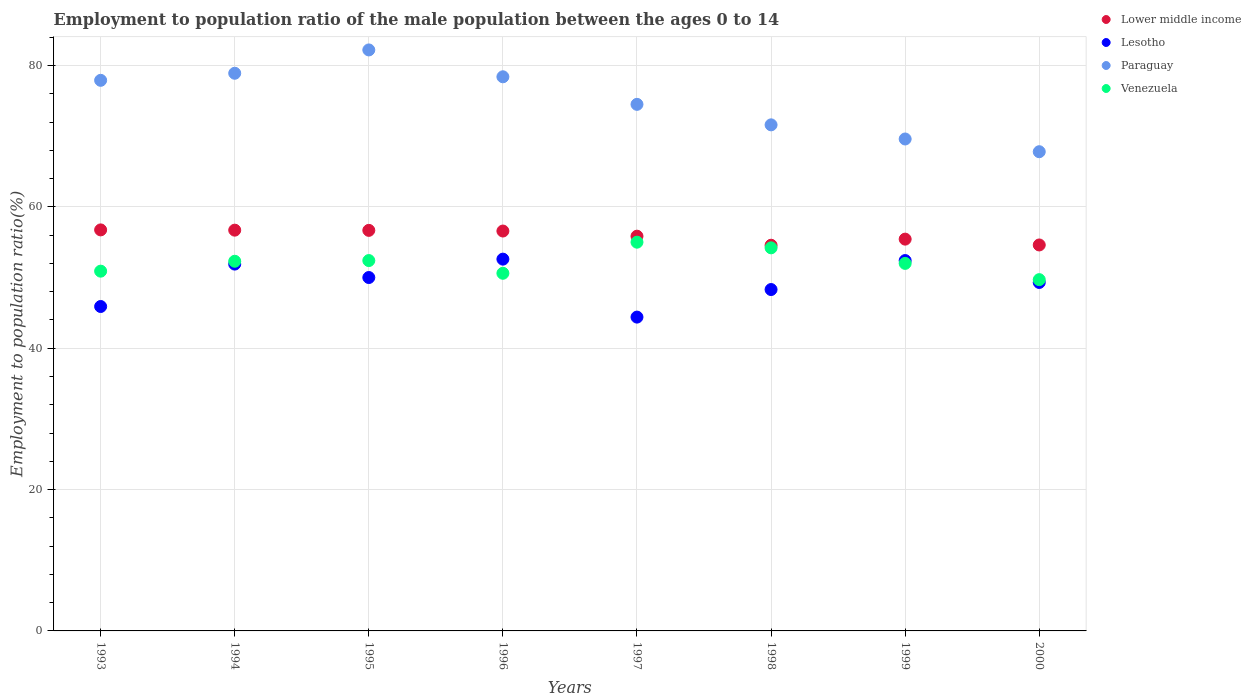How many different coloured dotlines are there?
Offer a very short reply. 4. Is the number of dotlines equal to the number of legend labels?
Your answer should be very brief. Yes. What is the employment to population ratio in Venezuela in 1996?
Your response must be concise. 50.6. Across all years, what is the maximum employment to population ratio in Lower middle income?
Give a very brief answer. 56.74. Across all years, what is the minimum employment to population ratio in Paraguay?
Your response must be concise. 67.8. In which year was the employment to population ratio in Paraguay minimum?
Your answer should be very brief. 2000. What is the total employment to population ratio in Lesotho in the graph?
Provide a succinct answer. 394.8. What is the difference between the employment to population ratio in Paraguay in 1997 and that in 2000?
Your answer should be compact. 6.7. What is the difference between the employment to population ratio in Paraguay in 1995 and the employment to population ratio in Lesotho in 1996?
Your answer should be compact. 29.6. What is the average employment to population ratio in Lesotho per year?
Your answer should be very brief. 49.35. In the year 1999, what is the difference between the employment to population ratio in Venezuela and employment to population ratio in Paraguay?
Keep it short and to the point. -17.6. What is the ratio of the employment to population ratio in Lower middle income in 1995 to that in 1996?
Provide a short and direct response. 1. Is the difference between the employment to population ratio in Venezuela in 1993 and 1999 greater than the difference between the employment to population ratio in Paraguay in 1993 and 1999?
Keep it short and to the point. No. What is the difference between the highest and the second highest employment to population ratio in Lesotho?
Make the answer very short. 0.2. What is the difference between the highest and the lowest employment to population ratio in Paraguay?
Ensure brevity in your answer.  14.4. In how many years, is the employment to population ratio in Lesotho greater than the average employment to population ratio in Lesotho taken over all years?
Make the answer very short. 4. Is the employment to population ratio in Venezuela strictly less than the employment to population ratio in Paraguay over the years?
Offer a very short reply. Yes. Are the values on the major ticks of Y-axis written in scientific E-notation?
Your answer should be compact. No. Does the graph contain any zero values?
Provide a succinct answer. No. Does the graph contain grids?
Offer a very short reply. Yes. Where does the legend appear in the graph?
Give a very brief answer. Top right. How many legend labels are there?
Your answer should be compact. 4. How are the legend labels stacked?
Offer a very short reply. Vertical. What is the title of the graph?
Your answer should be very brief. Employment to population ratio of the male population between the ages 0 to 14. What is the label or title of the X-axis?
Your answer should be compact. Years. What is the Employment to population ratio(%) of Lower middle income in 1993?
Make the answer very short. 56.74. What is the Employment to population ratio(%) of Lesotho in 1993?
Your response must be concise. 45.9. What is the Employment to population ratio(%) in Paraguay in 1993?
Ensure brevity in your answer.  77.9. What is the Employment to population ratio(%) of Venezuela in 1993?
Give a very brief answer. 50.9. What is the Employment to population ratio(%) in Lower middle income in 1994?
Provide a short and direct response. 56.7. What is the Employment to population ratio(%) in Lesotho in 1994?
Your answer should be compact. 51.9. What is the Employment to population ratio(%) in Paraguay in 1994?
Keep it short and to the point. 78.9. What is the Employment to population ratio(%) of Venezuela in 1994?
Make the answer very short. 52.3. What is the Employment to population ratio(%) of Lower middle income in 1995?
Your response must be concise. 56.67. What is the Employment to population ratio(%) in Paraguay in 1995?
Offer a terse response. 82.2. What is the Employment to population ratio(%) in Venezuela in 1995?
Your answer should be very brief. 52.4. What is the Employment to population ratio(%) in Lower middle income in 1996?
Ensure brevity in your answer.  56.58. What is the Employment to population ratio(%) in Lesotho in 1996?
Your answer should be very brief. 52.6. What is the Employment to population ratio(%) in Paraguay in 1996?
Give a very brief answer. 78.4. What is the Employment to population ratio(%) in Venezuela in 1996?
Provide a succinct answer. 50.6. What is the Employment to population ratio(%) in Lower middle income in 1997?
Your response must be concise. 55.85. What is the Employment to population ratio(%) of Lesotho in 1997?
Make the answer very short. 44.4. What is the Employment to population ratio(%) of Paraguay in 1997?
Your answer should be very brief. 74.5. What is the Employment to population ratio(%) of Venezuela in 1997?
Offer a very short reply. 55. What is the Employment to population ratio(%) in Lower middle income in 1998?
Your answer should be very brief. 54.57. What is the Employment to population ratio(%) in Lesotho in 1998?
Provide a succinct answer. 48.3. What is the Employment to population ratio(%) of Paraguay in 1998?
Keep it short and to the point. 71.6. What is the Employment to population ratio(%) in Venezuela in 1998?
Offer a very short reply. 54.2. What is the Employment to population ratio(%) in Lower middle income in 1999?
Offer a terse response. 55.43. What is the Employment to population ratio(%) of Lesotho in 1999?
Make the answer very short. 52.4. What is the Employment to population ratio(%) of Paraguay in 1999?
Give a very brief answer. 69.6. What is the Employment to population ratio(%) in Lower middle income in 2000?
Offer a terse response. 54.61. What is the Employment to population ratio(%) of Lesotho in 2000?
Provide a short and direct response. 49.3. What is the Employment to population ratio(%) in Paraguay in 2000?
Keep it short and to the point. 67.8. What is the Employment to population ratio(%) in Venezuela in 2000?
Ensure brevity in your answer.  49.7. Across all years, what is the maximum Employment to population ratio(%) in Lower middle income?
Offer a very short reply. 56.74. Across all years, what is the maximum Employment to population ratio(%) of Lesotho?
Your answer should be compact. 52.6. Across all years, what is the maximum Employment to population ratio(%) in Paraguay?
Make the answer very short. 82.2. Across all years, what is the minimum Employment to population ratio(%) in Lower middle income?
Your response must be concise. 54.57. Across all years, what is the minimum Employment to population ratio(%) of Lesotho?
Make the answer very short. 44.4. Across all years, what is the minimum Employment to population ratio(%) in Paraguay?
Keep it short and to the point. 67.8. Across all years, what is the minimum Employment to population ratio(%) of Venezuela?
Offer a terse response. 49.7. What is the total Employment to population ratio(%) in Lower middle income in the graph?
Your answer should be very brief. 447.14. What is the total Employment to population ratio(%) of Lesotho in the graph?
Your response must be concise. 394.8. What is the total Employment to population ratio(%) in Paraguay in the graph?
Provide a short and direct response. 600.9. What is the total Employment to population ratio(%) of Venezuela in the graph?
Your response must be concise. 417.1. What is the difference between the Employment to population ratio(%) in Lower middle income in 1993 and that in 1994?
Provide a succinct answer. 0.04. What is the difference between the Employment to population ratio(%) in Paraguay in 1993 and that in 1994?
Your answer should be very brief. -1. What is the difference between the Employment to population ratio(%) of Venezuela in 1993 and that in 1994?
Your answer should be compact. -1.4. What is the difference between the Employment to population ratio(%) in Lower middle income in 1993 and that in 1995?
Offer a terse response. 0.07. What is the difference between the Employment to population ratio(%) in Paraguay in 1993 and that in 1995?
Give a very brief answer. -4.3. What is the difference between the Employment to population ratio(%) of Lower middle income in 1993 and that in 1996?
Offer a terse response. 0.16. What is the difference between the Employment to population ratio(%) in Paraguay in 1993 and that in 1996?
Offer a terse response. -0.5. What is the difference between the Employment to population ratio(%) of Venezuela in 1993 and that in 1996?
Your answer should be very brief. 0.3. What is the difference between the Employment to population ratio(%) of Lower middle income in 1993 and that in 1997?
Your answer should be very brief. 0.89. What is the difference between the Employment to population ratio(%) of Paraguay in 1993 and that in 1997?
Provide a succinct answer. 3.4. What is the difference between the Employment to population ratio(%) of Venezuela in 1993 and that in 1997?
Ensure brevity in your answer.  -4.1. What is the difference between the Employment to population ratio(%) of Lower middle income in 1993 and that in 1998?
Give a very brief answer. 2.17. What is the difference between the Employment to population ratio(%) in Lesotho in 1993 and that in 1998?
Make the answer very short. -2.4. What is the difference between the Employment to population ratio(%) in Paraguay in 1993 and that in 1998?
Give a very brief answer. 6.3. What is the difference between the Employment to population ratio(%) in Venezuela in 1993 and that in 1998?
Ensure brevity in your answer.  -3.3. What is the difference between the Employment to population ratio(%) in Lower middle income in 1993 and that in 1999?
Give a very brief answer. 1.31. What is the difference between the Employment to population ratio(%) of Venezuela in 1993 and that in 1999?
Your answer should be compact. -1.1. What is the difference between the Employment to population ratio(%) of Lower middle income in 1993 and that in 2000?
Ensure brevity in your answer.  2.13. What is the difference between the Employment to population ratio(%) in Lesotho in 1993 and that in 2000?
Offer a terse response. -3.4. What is the difference between the Employment to population ratio(%) of Lower middle income in 1994 and that in 1995?
Provide a short and direct response. 0.03. What is the difference between the Employment to population ratio(%) of Venezuela in 1994 and that in 1995?
Offer a very short reply. -0.1. What is the difference between the Employment to population ratio(%) of Lower middle income in 1994 and that in 1996?
Provide a short and direct response. 0.12. What is the difference between the Employment to population ratio(%) in Lesotho in 1994 and that in 1996?
Offer a very short reply. -0.7. What is the difference between the Employment to population ratio(%) of Paraguay in 1994 and that in 1996?
Keep it short and to the point. 0.5. What is the difference between the Employment to population ratio(%) of Venezuela in 1994 and that in 1996?
Your response must be concise. 1.7. What is the difference between the Employment to population ratio(%) in Lower middle income in 1994 and that in 1997?
Provide a succinct answer. 0.85. What is the difference between the Employment to population ratio(%) of Lesotho in 1994 and that in 1997?
Ensure brevity in your answer.  7.5. What is the difference between the Employment to population ratio(%) of Lower middle income in 1994 and that in 1998?
Offer a terse response. 2.13. What is the difference between the Employment to population ratio(%) of Venezuela in 1994 and that in 1998?
Your answer should be very brief. -1.9. What is the difference between the Employment to population ratio(%) in Lower middle income in 1994 and that in 1999?
Ensure brevity in your answer.  1.27. What is the difference between the Employment to population ratio(%) in Lesotho in 1994 and that in 1999?
Your answer should be compact. -0.5. What is the difference between the Employment to population ratio(%) in Lower middle income in 1994 and that in 2000?
Make the answer very short. 2.1. What is the difference between the Employment to population ratio(%) in Venezuela in 1994 and that in 2000?
Provide a short and direct response. 2.6. What is the difference between the Employment to population ratio(%) in Lower middle income in 1995 and that in 1996?
Provide a succinct answer. 0.09. What is the difference between the Employment to population ratio(%) of Venezuela in 1995 and that in 1996?
Provide a short and direct response. 1.8. What is the difference between the Employment to population ratio(%) of Lower middle income in 1995 and that in 1997?
Provide a succinct answer. 0.82. What is the difference between the Employment to population ratio(%) in Lesotho in 1995 and that in 1997?
Offer a very short reply. 5.6. What is the difference between the Employment to population ratio(%) in Lower middle income in 1995 and that in 1998?
Give a very brief answer. 2.1. What is the difference between the Employment to population ratio(%) of Lesotho in 1995 and that in 1998?
Offer a terse response. 1.7. What is the difference between the Employment to population ratio(%) of Venezuela in 1995 and that in 1998?
Give a very brief answer. -1.8. What is the difference between the Employment to population ratio(%) in Lower middle income in 1995 and that in 1999?
Provide a short and direct response. 1.24. What is the difference between the Employment to population ratio(%) of Lesotho in 1995 and that in 1999?
Provide a succinct answer. -2.4. What is the difference between the Employment to population ratio(%) of Paraguay in 1995 and that in 1999?
Your answer should be very brief. 12.6. What is the difference between the Employment to population ratio(%) in Venezuela in 1995 and that in 1999?
Your response must be concise. 0.4. What is the difference between the Employment to population ratio(%) in Lower middle income in 1995 and that in 2000?
Offer a terse response. 2.07. What is the difference between the Employment to population ratio(%) of Paraguay in 1995 and that in 2000?
Your answer should be compact. 14.4. What is the difference between the Employment to population ratio(%) of Venezuela in 1995 and that in 2000?
Provide a short and direct response. 2.7. What is the difference between the Employment to population ratio(%) of Lower middle income in 1996 and that in 1997?
Your response must be concise. 0.73. What is the difference between the Employment to population ratio(%) in Paraguay in 1996 and that in 1997?
Make the answer very short. 3.9. What is the difference between the Employment to population ratio(%) of Venezuela in 1996 and that in 1997?
Keep it short and to the point. -4.4. What is the difference between the Employment to population ratio(%) in Lower middle income in 1996 and that in 1998?
Your answer should be compact. 2.01. What is the difference between the Employment to population ratio(%) in Lesotho in 1996 and that in 1998?
Provide a succinct answer. 4.3. What is the difference between the Employment to population ratio(%) of Paraguay in 1996 and that in 1998?
Offer a terse response. 6.8. What is the difference between the Employment to population ratio(%) in Lower middle income in 1996 and that in 1999?
Provide a short and direct response. 1.15. What is the difference between the Employment to population ratio(%) of Venezuela in 1996 and that in 1999?
Make the answer very short. -1.4. What is the difference between the Employment to population ratio(%) in Lower middle income in 1996 and that in 2000?
Your answer should be compact. 1.97. What is the difference between the Employment to population ratio(%) in Lesotho in 1996 and that in 2000?
Your answer should be compact. 3.3. What is the difference between the Employment to population ratio(%) of Venezuela in 1996 and that in 2000?
Ensure brevity in your answer.  0.9. What is the difference between the Employment to population ratio(%) in Lower middle income in 1997 and that in 1998?
Give a very brief answer. 1.28. What is the difference between the Employment to population ratio(%) in Venezuela in 1997 and that in 1998?
Your answer should be very brief. 0.8. What is the difference between the Employment to population ratio(%) of Lower middle income in 1997 and that in 1999?
Provide a short and direct response. 0.42. What is the difference between the Employment to population ratio(%) in Paraguay in 1997 and that in 1999?
Your response must be concise. 4.9. What is the difference between the Employment to population ratio(%) in Lower middle income in 1997 and that in 2000?
Offer a very short reply. 1.24. What is the difference between the Employment to population ratio(%) in Lesotho in 1997 and that in 2000?
Your response must be concise. -4.9. What is the difference between the Employment to population ratio(%) of Lower middle income in 1998 and that in 1999?
Offer a very short reply. -0.86. What is the difference between the Employment to population ratio(%) of Lower middle income in 1998 and that in 2000?
Give a very brief answer. -0.04. What is the difference between the Employment to population ratio(%) in Lesotho in 1998 and that in 2000?
Keep it short and to the point. -1. What is the difference between the Employment to population ratio(%) of Paraguay in 1998 and that in 2000?
Offer a very short reply. 3.8. What is the difference between the Employment to population ratio(%) in Lower middle income in 1999 and that in 2000?
Ensure brevity in your answer.  0.83. What is the difference between the Employment to population ratio(%) of Lower middle income in 1993 and the Employment to population ratio(%) of Lesotho in 1994?
Give a very brief answer. 4.84. What is the difference between the Employment to population ratio(%) in Lower middle income in 1993 and the Employment to population ratio(%) in Paraguay in 1994?
Offer a very short reply. -22.16. What is the difference between the Employment to population ratio(%) of Lower middle income in 1993 and the Employment to population ratio(%) of Venezuela in 1994?
Your answer should be compact. 4.44. What is the difference between the Employment to population ratio(%) of Lesotho in 1993 and the Employment to population ratio(%) of Paraguay in 1994?
Offer a terse response. -33. What is the difference between the Employment to population ratio(%) of Paraguay in 1993 and the Employment to population ratio(%) of Venezuela in 1994?
Your answer should be very brief. 25.6. What is the difference between the Employment to population ratio(%) of Lower middle income in 1993 and the Employment to population ratio(%) of Lesotho in 1995?
Your response must be concise. 6.74. What is the difference between the Employment to population ratio(%) of Lower middle income in 1993 and the Employment to population ratio(%) of Paraguay in 1995?
Offer a terse response. -25.46. What is the difference between the Employment to population ratio(%) in Lower middle income in 1993 and the Employment to population ratio(%) in Venezuela in 1995?
Your answer should be compact. 4.34. What is the difference between the Employment to population ratio(%) in Lesotho in 1993 and the Employment to population ratio(%) in Paraguay in 1995?
Your response must be concise. -36.3. What is the difference between the Employment to population ratio(%) of Lower middle income in 1993 and the Employment to population ratio(%) of Lesotho in 1996?
Offer a terse response. 4.14. What is the difference between the Employment to population ratio(%) of Lower middle income in 1993 and the Employment to population ratio(%) of Paraguay in 1996?
Your answer should be compact. -21.66. What is the difference between the Employment to population ratio(%) in Lower middle income in 1993 and the Employment to population ratio(%) in Venezuela in 1996?
Keep it short and to the point. 6.14. What is the difference between the Employment to population ratio(%) in Lesotho in 1993 and the Employment to population ratio(%) in Paraguay in 1996?
Provide a short and direct response. -32.5. What is the difference between the Employment to population ratio(%) of Paraguay in 1993 and the Employment to population ratio(%) of Venezuela in 1996?
Your answer should be compact. 27.3. What is the difference between the Employment to population ratio(%) in Lower middle income in 1993 and the Employment to population ratio(%) in Lesotho in 1997?
Offer a very short reply. 12.34. What is the difference between the Employment to population ratio(%) of Lower middle income in 1993 and the Employment to population ratio(%) of Paraguay in 1997?
Give a very brief answer. -17.76. What is the difference between the Employment to population ratio(%) of Lower middle income in 1993 and the Employment to population ratio(%) of Venezuela in 1997?
Offer a terse response. 1.74. What is the difference between the Employment to population ratio(%) in Lesotho in 1993 and the Employment to population ratio(%) in Paraguay in 1997?
Provide a short and direct response. -28.6. What is the difference between the Employment to population ratio(%) in Lesotho in 1993 and the Employment to population ratio(%) in Venezuela in 1997?
Offer a very short reply. -9.1. What is the difference between the Employment to population ratio(%) in Paraguay in 1993 and the Employment to population ratio(%) in Venezuela in 1997?
Give a very brief answer. 22.9. What is the difference between the Employment to population ratio(%) in Lower middle income in 1993 and the Employment to population ratio(%) in Lesotho in 1998?
Ensure brevity in your answer.  8.44. What is the difference between the Employment to population ratio(%) of Lower middle income in 1993 and the Employment to population ratio(%) of Paraguay in 1998?
Your answer should be very brief. -14.86. What is the difference between the Employment to population ratio(%) of Lower middle income in 1993 and the Employment to population ratio(%) of Venezuela in 1998?
Keep it short and to the point. 2.54. What is the difference between the Employment to population ratio(%) of Lesotho in 1993 and the Employment to population ratio(%) of Paraguay in 1998?
Give a very brief answer. -25.7. What is the difference between the Employment to population ratio(%) in Lesotho in 1993 and the Employment to population ratio(%) in Venezuela in 1998?
Your response must be concise. -8.3. What is the difference between the Employment to population ratio(%) of Paraguay in 1993 and the Employment to population ratio(%) of Venezuela in 1998?
Make the answer very short. 23.7. What is the difference between the Employment to population ratio(%) of Lower middle income in 1993 and the Employment to population ratio(%) of Lesotho in 1999?
Offer a terse response. 4.34. What is the difference between the Employment to population ratio(%) in Lower middle income in 1993 and the Employment to population ratio(%) in Paraguay in 1999?
Give a very brief answer. -12.86. What is the difference between the Employment to population ratio(%) in Lower middle income in 1993 and the Employment to population ratio(%) in Venezuela in 1999?
Your response must be concise. 4.74. What is the difference between the Employment to population ratio(%) in Lesotho in 1993 and the Employment to population ratio(%) in Paraguay in 1999?
Your answer should be very brief. -23.7. What is the difference between the Employment to population ratio(%) of Paraguay in 1993 and the Employment to population ratio(%) of Venezuela in 1999?
Your response must be concise. 25.9. What is the difference between the Employment to population ratio(%) of Lower middle income in 1993 and the Employment to population ratio(%) of Lesotho in 2000?
Ensure brevity in your answer.  7.44. What is the difference between the Employment to population ratio(%) of Lower middle income in 1993 and the Employment to population ratio(%) of Paraguay in 2000?
Your response must be concise. -11.06. What is the difference between the Employment to population ratio(%) of Lower middle income in 1993 and the Employment to population ratio(%) of Venezuela in 2000?
Make the answer very short. 7.04. What is the difference between the Employment to population ratio(%) of Lesotho in 1993 and the Employment to population ratio(%) of Paraguay in 2000?
Offer a very short reply. -21.9. What is the difference between the Employment to population ratio(%) of Paraguay in 1993 and the Employment to population ratio(%) of Venezuela in 2000?
Keep it short and to the point. 28.2. What is the difference between the Employment to population ratio(%) in Lower middle income in 1994 and the Employment to population ratio(%) in Lesotho in 1995?
Your response must be concise. 6.7. What is the difference between the Employment to population ratio(%) of Lower middle income in 1994 and the Employment to population ratio(%) of Paraguay in 1995?
Your answer should be compact. -25.5. What is the difference between the Employment to population ratio(%) in Lower middle income in 1994 and the Employment to population ratio(%) in Venezuela in 1995?
Make the answer very short. 4.3. What is the difference between the Employment to population ratio(%) of Lesotho in 1994 and the Employment to population ratio(%) of Paraguay in 1995?
Give a very brief answer. -30.3. What is the difference between the Employment to population ratio(%) of Paraguay in 1994 and the Employment to population ratio(%) of Venezuela in 1995?
Provide a short and direct response. 26.5. What is the difference between the Employment to population ratio(%) in Lower middle income in 1994 and the Employment to population ratio(%) in Lesotho in 1996?
Offer a terse response. 4.1. What is the difference between the Employment to population ratio(%) of Lower middle income in 1994 and the Employment to population ratio(%) of Paraguay in 1996?
Provide a short and direct response. -21.7. What is the difference between the Employment to population ratio(%) of Lower middle income in 1994 and the Employment to population ratio(%) of Venezuela in 1996?
Provide a succinct answer. 6.1. What is the difference between the Employment to population ratio(%) in Lesotho in 1994 and the Employment to population ratio(%) in Paraguay in 1996?
Provide a succinct answer. -26.5. What is the difference between the Employment to population ratio(%) in Paraguay in 1994 and the Employment to population ratio(%) in Venezuela in 1996?
Provide a short and direct response. 28.3. What is the difference between the Employment to population ratio(%) of Lower middle income in 1994 and the Employment to population ratio(%) of Lesotho in 1997?
Provide a short and direct response. 12.3. What is the difference between the Employment to population ratio(%) in Lower middle income in 1994 and the Employment to population ratio(%) in Paraguay in 1997?
Offer a very short reply. -17.8. What is the difference between the Employment to population ratio(%) of Lower middle income in 1994 and the Employment to population ratio(%) of Venezuela in 1997?
Offer a terse response. 1.7. What is the difference between the Employment to population ratio(%) in Lesotho in 1994 and the Employment to population ratio(%) in Paraguay in 1997?
Your response must be concise. -22.6. What is the difference between the Employment to population ratio(%) of Paraguay in 1994 and the Employment to population ratio(%) of Venezuela in 1997?
Make the answer very short. 23.9. What is the difference between the Employment to population ratio(%) in Lower middle income in 1994 and the Employment to population ratio(%) in Lesotho in 1998?
Offer a terse response. 8.4. What is the difference between the Employment to population ratio(%) of Lower middle income in 1994 and the Employment to population ratio(%) of Paraguay in 1998?
Ensure brevity in your answer.  -14.9. What is the difference between the Employment to population ratio(%) in Lower middle income in 1994 and the Employment to population ratio(%) in Venezuela in 1998?
Provide a succinct answer. 2.5. What is the difference between the Employment to population ratio(%) in Lesotho in 1994 and the Employment to population ratio(%) in Paraguay in 1998?
Offer a very short reply. -19.7. What is the difference between the Employment to population ratio(%) in Lesotho in 1994 and the Employment to population ratio(%) in Venezuela in 1998?
Keep it short and to the point. -2.3. What is the difference between the Employment to population ratio(%) of Paraguay in 1994 and the Employment to population ratio(%) of Venezuela in 1998?
Your answer should be compact. 24.7. What is the difference between the Employment to population ratio(%) in Lower middle income in 1994 and the Employment to population ratio(%) in Lesotho in 1999?
Provide a short and direct response. 4.3. What is the difference between the Employment to population ratio(%) in Lower middle income in 1994 and the Employment to population ratio(%) in Paraguay in 1999?
Offer a very short reply. -12.9. What is the difference between the Employment to population ratio(%) in Lower middle income in 1994 and the Employment to population ratio(%) in Venezuela in 1999?
Make the answer very short. 4.7. What is the difference between the Employment to population ratio(%) of Lesotho in 1994 and the Employment to population ratio(%) of Paraguay in 1999?
Ensure brevity in your answer.  -17.7. What is the difference between the Employment to population ratio(%) of Paraguay in 1994 and the Employment to population ratio(%) of Venezuela in 1999?
Offer a very short reply. 26.9. What is the difference between the Employment to population ratio(%) of Lower middle income in 1994 and the Employment to population ratio(%) of Lesotho in 2000?
Provide a short and direct response. 7.4. What is the difference between the Employment to population ratio(%) in Lower middle income in 1994 and the Employment to population ratio(%) in Paraguay in 2000?
Make the answer very short. -11.1. What is the difference between the Employment to population ratio(%) in Lower middle income in 1994 and the Employment to population ratio(%) in Venezuela in 2000?
Offer a terse response. 7. What is the difference between the Employment to population ratio(%) in Lesotho in 1994 and the Employment to population ratio(%) in Paraguay in 2000?
Make the answer very short. -15.9. What is the difference between the Employment to population ratio(%) in Paraguay in 1994 and the Employment to population ratio(%) in Venezuela in 2000?
Provide a short and direct response. 29.2. What is the difference between the Employment to population ratio(%) in Lower middle income in 1995 and the Employment to population ratio(%) in Lesotho in 1996?
Offer a very short reply. 4.07. What is the difference between the Employment to population ratio(%) in Lower middle income in 1995 and the Employment to population ratio(%) in Paraguay in 1996?
Provide a short and direct response. -21.73. What is the difference between the Employment to population ratio(%) of Lower middle income in 1995 and the Employment to population ratio(%) of Venezuela in 1996?
Offer a terse response. 6.07. What is the difference between the Employment to population ratio(%) of Lesotho in 1995 and the Employment to population ratio(%) of Paraguay in 1996?
Ensure brevity in your answer.  -28.4. What is the difference between the Employment to population ratio(%) of Lesotho in 1995 and the Employment to population ratio(%) of Venezuela in 1996?
Make the answer very short. -0.6. What is the difference between the Employment to population ratio(%) of Paraguay in 1995 and the Employment to population ratio(%) of Venezuela in 1996?
Offer a very short reply. 31.6. What is the difference between the Employment to population ratio(%) of Lower middle income in 1995 and the Employment to population ratio(%) of Lesotho in 1997?
Your answer should be very brief. 12.27. What is the difference between the Employment to population ratio(%) of Lower middle income in 1995 and the Employment to population ratio(%) of Paraguay in 1997?
Ensure brevity in your answer.  -17.83. What is the difference between the Employment to population ratio(%) in Lower middle income in 1995 and the Employment to population ratio(%) in Venezuela in 1997?
Offer a terse response. 1.67. What is the difference between the Employment to population ratio(%) of Lesotho in 1995 and the Employment to population ratio(%) of Paraguay in 1997?
Give a very brief answer. -24.5. What is the difference between the Employment to population ratio(%) in Lesotho in 1995 and the Employment to population ratio(%) in Venezuela in 1997?
Make the answer very short. -5. What is the difference between the Employment to population ratio(%) of Paraguay in 1995 and the Employment to population ratio(%) of Venezuela in 1997?
Offer a very short reply. 27.2. What is the difference between the Employment to population ratio(%) in Lower middle income in 1995 and the Employment to population ratio(%) in Lesotho in 1998?
Your answer should be compact. 8.37. What is the difference between the Employment to population ratio(%) of Lower middle income in 1995 and the Employment to population ratio(%) of Paraguay in 1998?
Offer a very short reply. -14.93. What is the difference between the Employment to population ratio(%) in Lower middle income in 1995 and the Employment to population ratio(%) in Venezuela in 1998?
Your response must be concise. 2.47. What is the difference between the Employment to population ratio(%) in Lesotho in 1995 and the Employment to population ratio(%) in Paraguay in 1998?
Keep it short and to the point. -21.6. What is the difference between the Employment to population ratio(%) in Lesotho in 1995 and the Employment to population ratio(%) in Venezuela in 1998?
Keep it short and to the point. -4.2. What is the difference between the Employment to population ratio(%) of Paraguay in 1995 and the Employment to population ratio(%) of Venezuela in 1998?
Provide a short and direct response. 28. What is the difference between the Employment to population ratio(%) in Lower middle income in 1995 and the Employment to population ratio(%) in Lesotho in 1999?
Offer a terse response. 4.27. What is the difference between the Employment to population ratio(%) in Lower middle income in 1995 and the Employment to population ratio(%) in Paraguay in 1999?
Your answer should be very brief. -12.93. What is the difference between the Employment to population ratio(%) of Lower middle income in 1995 and the Employment to population ratio(%) of Venezuela in 1999?
Make the answer very short. 4.67. What is the difference between the Employment to population ratio(%) in Lesotho in 1995 and the Employment to population ratio(%) in Paraguay in 1999?
Ensure brevity in your answer.  -19.6. What is the difference between the Employment to population ratio(%) in Paraguay in 1995 and the Employment to population ratio(%) in Venezuela in 1999?
Your answer should be very brief. 30.2. What is the difference between the Employment to population ratio(%) of Lower middle income in 1995 and the Employment to population ratio(%) of Lesotho in 2000?
Provide a short and direct response. 7.37. What is the difference between the Employment to population ratio(%) of Lower middle income in 1995 and the Employment to population ratio(%) of Paraguay in 2000?
Give a very brief answer. -11.13. What is the difference between the Employment to population ratio(%) of Lower middle income in 1995 and the Employment to population ratio(%) of Venezuela in 2000?
Provide a succinct answer. 6.97. What is the difference between the Employment to population ratio(%) of Lesotho in 1995 and the Employment to population ratio(%) of Paraguay in 2000?
Make the answer very short. -17.8. What is the difference between the Employment to population ratio(%) of Lesotho in 1995 and the Employment to population ratio(%) of Venezuela in 2000?
Keep it short and to the point. 0.3. What is the difference between the Employment to population ratio(%) of Paraguay in 1995 and the Employment to population ratio(%) of Venezuela in 2000?
Your answer should be very brief. 32.5. What is the difference between the Employment to population ratio(%) in Lower middle income in 1996 and the Employment to population ratio(%) in Lesotho in 1997?
Your answer should be compact. 12.18. What is the difference between the Employment to population ratio(%) in Lower middle income in 1996 and the Employment to population ratio(%) in Paraguay in 1997?
Provide a succinct answer. -17.92. What is the difference between the Employment to population ratio(%) of Lower middle income in 1996 and the Employment to population ratio(%) of Venezuela in 1997?
Provide a short and direct response. 1.58. What is the difference between the Employment to population ratio(%) of Lesotho in 1996 and the Employment to population ratio(%) of Paraguay in 1997?
Ensure brevity in your answer.  -21.9. What is the difference between the Employment to population ratio(%) of Lesotho in 1996 and the Employment to population ratio(%) of Venezuela in 1997?
Provide a short and direct response. -2.4. What is the difference between the Employment to population ratio(%) in Paraguay in 1996 and the Employment to population ratio(%) in Venezuela in 1997?
Your response must be concise. 23.4. What is the difference between the Employment to population ratio(%) of Lower middle income in 1996 and the Employment to population ratio(%) of Lesotho in 1998?
Your answer should be compact. 8.28. What is the difference between the Employment to population ratio(%) in Lower middle income in 1996 and the Employment to population ratio(%) in Paraguay in 1998?
Offer a very short reply. -15.02. What is the difference between the Employment to population ratio(%) in Lower middle income in 1996 and the Employment to population ratio(%) in Venezuela in 1998?
Give a very brief answer. 2.38. What is the difference between the Employment to population ratio(%) of Lesotho in 1996 and the Employment to population ratio(%) of Venezuela in 1998?
Your answer should be compact. -1.6. What is the difference between the Employment to population ratio(%) in Paraguay in 1996 and the Employment to population ratio(%) in Venezuela in 1998?
Your answer should be compact. 24.2. What is the difference between the Employment to population ratio(%) of Lower middle income in 1996 and the Employment to population ratio(%) of Lesotho in 1999?
Offer a terse response. 4.18. What is the difference between the Employment to population ratio(%) in Lower middle income in 1996 and the Employment to population ratio(%) in Paraguay in 1999?
Offer a terse response. -13.02. What is the difference between the Employment to population ratio(%) in Lower middle income in 1996 and the Employment to population ratio(%) in Venezuela in 1999?
Give a very brief answer. 4.58. What is the difference between the Employment to population ratio(%) of Paraguay in 1996 and the Employment to population ratio(%) of Venezuela in 1999?
Make the answer very short. 26.4. What is the difference between the Employment to population ratio(%) in Lower middle income in 1996 and the Employment to population ratio(%) in Lesotho in 2000?
Keep it short and to the point. 7.28. What is the difference between the Employment to population ratio(%) in Lower middle income in 1996 and the Employment to population ratio(%) in Paraguay in 2000?
Your answer should be very brief. -11.22. What is the difference between the Employment to population ratio(%) in Lower middle income in 1996 and the Employment to population ratio(%) in Venezuela in 2000?
Your answer should be very brief. 6.88. What is the difference between the Employment to population ratio(%) in Lesotho in 1996 and the Employment to population ratio(%) in Paraguay in 2000?
Your response must be concise. -15.2. What is the difference between the Employment to population ratio(%) of Paraguay in 1996 and the Employment to population ratio(%) of Venezuela in 2000?
Provide a short and direct response. 28.7. What is the difference between the Employment to population ratio(%) in Lower middle income in 1997 and the Employment to population ratio(%) in Lesotho in 1998?
Your answer should be compact. 7.55. What is the difference between the Employment to population ratio(%) in Lower middle income in 1997 and the Employment to population ratio(%) in Paraguay in 1998?
Your answer should be very brief. -15.75. What is the difference between the Employment to population ratio(%) of Lower middle income in 1997 and the Employment to population ratio(%) of Venezuela in 1998?
Provide a short and direct response. 1.65. What is the difference between the Employment to population ratio(%) in Lesotho in 1997 and the Employment to population ratio(%) in Paraguay in 1998?
Keep it short and to the point. -27.2. What is the difference between the Employment to population ratio(%) of Lesotho in 1997 and the Employment to population ratio(%) of Venezuela in 1998?
Offer a terse response. -9.8. What is the difference between the Employment to population ratio(%) in Paraguay in 1997 and the Employment to population ratio(%) in Venezuela in 1998?
Ensure brevity in your answer.  20.3. What is the difference between the Employment to population ratio(%) in Lower middle income in 1997 and the Employment to population ratio(%) in Lesotho in 1999?
Give a very brief answer. 3.45. What is the difference between the Employment to population ratio(%) of Lower middle income in 1997 and the Employment to population ratio(%) of Paraguay in 1999?
Your answer should be compact. -13.75. What is the difference between the Employment to population ratio(%) in Lower middle income in 1997 and the Employment to population ratio(%) in Venezuela in 1999?
Make the answer very short. 3.85. What is the difference between the Employment to population ratio(%) in Lesotho in 1997 and the Employment to population ratio(%) in Paraguay in 1999?
Your answer should be very brief. -25.2. What is the difference between the Employment to population ratio(%) in Lower middle income in 1997 and the Employment to population ratio(%) in Lesotho in 2000?
Your response must be concise. 6.55. What is the difference between the Employment to population ratio(%) in Lower middle income in 1997 and the Employment to population ratio(%) in Paraguay in 2000?
Offer a terse response. -11.95. What is the difference between the Employment to population ratio(%) in Lower middle income in 1997 and the Employment to population ratio(%) in Venezuela in 2000?
Offer a very short reply. 6.15. What is the difference between the Employment to population ratio(%) in Lesotho in 1997 and the Employment to population ratio(%) in Paraguay in 2000?
Your answer should be very brief. -23.4. What is the difference between the Employment to population ratio(%) in Lesotho in 1997 and the Employment to population ratio(%) in Venezuela in 2000?
Your answer should be very brief. -5.3. What is the difference between the Employment to population ratio(%) in Paraguay in 1997 and the Employment to population ratio(%) in Venezuela in 2000?
Your answer should be compact. 24.8. What is the difference between the Employment to population ratio(%) in Lower middle income in 1998 and the Employment to population ratio(%) in Lesotho in 1999?
Your answer should be compact. 2.17. What is the difference between the Employment to population ratio(%) in Lower middle income in 1998 and the Employment to population ratio(%) in Paraguay in 1999?
Make the answer very short. -15.03. What is the difference between the Employment to population ratio(%) in Lower middle income in 1998 and the Employment to population ratio(%) in Venezuela in 1999?
Your answer should be compact. 2.57. What is the difference between the Employment to population ratio(%) of Lesotho in 1998 and the Employment to population ratio(%) of Paraguay in 1999?
Give a very brief answer. -21.3. What is the difference between the Employment to population ratio(%) in Lesotho in 1998 and the Employment to population ratio(%) in Venezuela in 1999?
Provide a succinct answer. -3.7. What is the difference between the Employment to population ratio(%) of Paraguay in 1998 and the Employment to population ratio(%) of Venezuela in 1999?
Your answer should be compact. 19.6. What is the difference between the Employment to population ratio(%) of Lower middle income in 1998 and the Employment to population ratio(%) of Lesotho in 2000?
Ensure brevity in your answer.  5.27. What is the difference between the Employment to population ratio(%) in Lower middle income in 1998 and the Employment to population ratio(%) in Paraguay in 2000?
Offer a terse response. -13.23. What is the difference between the Employment to population ratio(%) of Lower middle income in 1998 and the Employment to population ratio(%) of Venezuela in 2000?
Ensure brevity in your answer.  4.87. What is the difference between the Employment to population ratio(%) in Lesotho in 1998 and the Employment to population ratio(%) in Paraguay in 2000?
Your answer should be compact. -19.5. What is the difference between the Employment to population ratio(%) of Lesotho in 1998 and the Employment to population ratio(%) of Venezuela in 2000?
Keep it short and to the point. -1.4. What is the difference between the Employment to population ratio(%) in Paraguay in 1998 and the Employment to population ratio(%) in Venezuela in 2000?
Your answer should be compact. 21.9. What is the difference between the Employment to population ratio(%) of Lower middle income in 1999 and the Employment to population ratio(%) of Lesotho in 2000?
Ensure brevity in your answer.  6.13. What is the difference between the Employment to population ratio(%) in Lower middle income in 1999 and the Employment to population ratio(%) in Paraguay in 2000?
Give a very brief answer. -12.37. What is the difference between the Employment to population ratio(%) in Lower middle income in 1999 and the Employment to population ratio(%) in Venezuela in 2000?
Your answer should be very brief. 5.73. What is the difference between the Employment to population ratio(%) of Lesotho in 1999 and the Employment to population ratio(%) of Paraguay in 2000?
Provide a succinct answer. -15.4. What is the difference between the Employment to population ratio(%) in Lesotho in 1999 and the Employment to population ratio(%) in Venezuela in 2000?
Provide a succinct answer. 2.7. What is the difference between the Employment to population ratio(%) of Paraguay in 1999 and the Employment to population ratio(%) of Venezuela in 2000?
Provide a succinct answer. 19.9. What is the average Employment to population ratio(%) in Lower middle income per year?
Give a very brief answer. 55.89. What is the average Employment to population ratio(%) of Lesotho per year?
Provide a succinct answer. 49.35. What is the average Employment to population ratio(%) in Paraguay per year?
Your answer should be very brief. 75.11. What is the average Employment to population ratio(%) in Venezuela per year?
Your response must be concise. 52.14. In the year 1993, what is the difference between the Employment to population ratio(%) of Lower middle income and Employment to population ratio(%) of Lesotho?
Make the answer very short. 10.84. In the year 1993, what is the difference between the Employment to population ratio(%) of Lower middle income and Employment to population ratio(%) of Paraguay?
Ensure brevity in your answer.  -21.16. In the year 1993, what is the difference between the Employment to population ratio(%) of Lower middle income and Employment to population ratio(%) of Venezuela?
Your response must be concise. 5.84. In the year 1993, what is the difference between the Employment to population ratio(%) in Lesotho and Employment to population ratio(%) in Paraguay?
Give a very brief answer. -32. In the year 1993, what is the difference between the Employment to population ratio(%) in Paraguay and Employment to population ratio(%) in Venezuela?
Provide a succinct answer. 27. In the year 1994, what is the difference between the Employment to population ratio(%) in Lower middle income and Employment to population ratio(%) in Lesotho?
Ensure brevity in your answer.  4.8. In the year 1994, what is the difference between the Employment to population ratio(%) of Lower middle income and Employment to population ratio(%) of Paraguay?
Ensure brevity in your answer.  -22.2. In the year 1994, what is the difference between the Employment to population ratio(%) of Lower middle income and Employment to population ratio(%) of Venezuela?
Your response must be concise. 4.4. In the year 1994, what is the difference between the Employment to population ratio(%) of Paraguay and Employment to population ratio(%) of Venezuela?
Provide a succinct answer. 26.6. In the year 1995, what is the difference between the Employment to population ratio(%) in Lower middle income and Employment to population ratio(%) in Lesotho?
Your answer should be compact. 6.67. In the year 1995, what is the difference between the Employment to population ratio(%) of Lower middle income and Employment to population ratio(%) of Paraguay?
Make the answer very short. -25.53. In the year 1995, what is the difference between the Employment to population ratio(%) in Lower middle income and Employment to population ratio(%) in Venezuela?
Make the answer very short. 4.27. In the year 1995, what is the difference between the Employment to population ratio(%) in Lesotho and Employment to population ratio(%) in Paraguay?
Keep it short and to the point. -32.2. In the year 1995, what is the difference between the Employment to population ratio(%) of Lesotho and Employment to population ratio(%) of Venezuela?
Provide a succinct answer. -2.4. In the year 1995, what is the difference between the Employment to population ratio(%) of Paraguay and Employment to population ratio(%) of Venezuela?
Keep it short and to the point. 29.8. In the year 1996, what is the difference between the Employment to population ratio(%) in Lower middle income and Employment to population ratio(%) in Lesotho?
Your response must be concise. 3.98. In the year 1996, what is the difference between the Employment to population ratio(%) of Lower middle income and Employment to population ratio(%) of Paraguay?
Offer a very short reply. -21.82. In the year 1996, what is the difference between the Employment to population ratio(%) in Lower middle income and Employment to population ratio(%) in Venezuela?
Your answer should be compact. 5.98. In the year 1996, what is the difference between the Employment to population ratio(%) of Lesotho and Employment to population ratio(%) of Paraguay?
Give a very brief answer. -25.8. In the year 1996, what is the difference between the Employment to population ratio(%) in Lesotho and Employment to population ratio(%) in Venezuela?
Ensure brevity in your answer.  2. In the year 1996, what is the difference between the Employment to population ratio(%) in Paraguay and Employment to population ratio(%) in Venezuela?
Your answer should be very brief. 27.8. In the year 1997, what is the difference between the Employment to population ratio(%) in Lower middle income and Employment to population ratio(%) in Lesotho?
Ensure brevity in your answer.  11.45. In the year 1997, what is the difference between the Employment to population ratio(%) of Lower middle income and Employment to population ratio(%) of Paraguay?
Keep it short and to the point. -18.65. In the year 1997, what is the difference between the Employment to population ratio(%) of Lower middle income and Employment to population ratio(%) of Venezuela?
Your answer should be compact. 0.85. In the year 1997, what is the difference between the Employment to population ratio(%) in Lesotho and Employment to population ratio(%) in Paraguay?
Provide a short and direct response. -30.1. In the year 1997, what is the difference between the Employment to population ratio(%) of Lesotho and Employment to population ratio(%) of Venezuela?
Ensure brevity in your answer.  -10.6. In the year 1998, what is the difference between the Employment to population ratio(%) of Lower middle income and Employment to population ratio(%) of Lesotho?
Your response must be concise. 6.27. In the year 1998, what is the difference between the Employment to population ratio(%) of Lower middle income and Employment to population ratio(%) of Paraguay?
Offer a terse response. -17.03. In the year 1998, what is the difference between the Employment to population ratio(%) of Lower middle income and Employment to population ratio(%) of Venezuela?
Offer a terse response. 0.37. In the year 1998, what is the difference between the Employment to population ratio(%) of Lesotho and Employment to population ratio(%) of Paraguay?
Offer a very short reply. -23.3. In the year 1999, what is the difference between the Employment to population ratio(%) in Lower middle income and Employment to population ratio(%) in Lesotho?
Provide a short and direct response. 3.03. In the year 1999, what is the difference between the Employment to population ratio(%) in Lower middle income and Employment to population ratio(%) in Paraguay?
Your answer should be very brief. -14.17. In the year 1999, what is the difference between the Employment to population ratio(%) in Lower middle income and Employment to population ratio(%) in Venezuela?
Make the answer very short. 3.43. In the year 1999, what is the difference between the Employment to population ratio(%) of Lesotho and Employment to population ratio(%) of Paraguay?
Provide a succinct answer. -17.2. In the year 1999, what is the difference between the Employment to population ratio(%) in Lesotho and Employment to population ratio(%) in Venezuela?
Give a very brief answer. 0.4. In the year 1999, what is the difference between the Employment to population ratio(%) in Paraguay and Employment to population ratio(%) in Venezuela?
Your response must be concise. 17.6. In the year 2000, what is the difference between the Employment to population ratio(%) in Lower middle income and Employment to population ratio(%) in Lesotho?
Provide a short and direct response. 5.31. In the year 2000, what is the difference between the Employment to population ratio(%) of Lower middle income and Employment to population ratio(%) of Paraguay?
Keep it short and to the point. -13.19. In the year 2000, what is the difference between the Employment to population ratio(%) of Lower middle income and Employment to population ratio(%) of Venezuela?
Make the answer very short. 4.91. In the year 2000, what is the difference between the Employment to population ratio(%) of Lesotho and Employment to population ratio(%) of Paraguay?
Your response must be concise. -18.5. What is the ratio of the Employment to population ratio(%) in Lesotho in 1993 to that in 1994?
Keep it short and to the point. 0.88. What is the ratio of the Employment to population ratio(%) of Paraguay in 1993 to that in 1994?
Your response must be concise. 0.99. What is the ratio of the Employment to population ratio(%) of Venezuela in 1993 to that in 1994?
Offer a terse response. 0.97. What is the ratio of the Employment to population ratio(%) of Lower middle income in 1993 to that in 1995?
Provide a short and direct response. 1. What is the ratio of the Employment to population ratio(%) in Lesotho in 1993 to that in 1995?
Keep it short and to the point. 0.92. What is the ratio of the Employment to population ratio(%) of Paraguay in 1993 to that in 1995?
Give a very brief answer. 0.95. What is the ratio of the Employment to population ratio(%) of Venezuela in 1993 to that in 1995?
Provide a succinct answer. 0.97. What is the ratio of the Employment to population ratio(%) of Lesotho in 1993 to that in 1996?
Give a very brief answer. 0.87. What is the ratio of the Employment to population ratio(%) of Paraguay in 1993 to that in 1996?
Provide a succinct answer. 0.99. What is the ratio of the Employment to population ratio(%) in Venezuela in 1993 to that in 1996?
Ensure brevity in your answer.  1.01. What is the ratio of the Employment to population ratio(%) in Lower middle income in 1993 to that in 1997?
Provide a short and direct response. 1.02. What is the ratio of the Employment to population ratio(%) in Lesotho in 1993 to that in 1997?
Keep it short and to the point. 1.03. What is the ratio of the Employment to population ratio(%) of Paraguay in 1993 to that in 1997?
Your answer should be compact. 1.05. What is the ratio of the Employment to population ratio(%) of Venezuela in 1993 to that in 1997?
Offer a terse response. 0.93. What is the ratio of the Employment to population ratio(%) in Lower middle income in 1993 to that in 1998?
Provide a succinct answer. 1.04. What is the ratio of the Employment to population ratio(%) of Lesotho in 1993 to that in 1998?
Your answer should be compact. 0.95. What is the ratio of the Employment to population ratio(%) of Paraguay in 1993 to that in 1998?
Your answer should be compact. 1.09. What is the ratio of the Employment to population ratio(%) in Venezuela in 1993 to that in 1998?
Your answer should be compact. 0.94. What is the ratio of the Employment to population ratio(%) of Lower middle income in 1993 to that in 1999?
Provide a succinct answer. 1.02. What is the ratio of the Employment to population ratio(%) in Lesotho in 1993 to that in 1999?
Your answer should be very brief. 0.88. What is the ratio of the Employment to population ratio(%) of Paraguay in 1993 to that in 1999?
Make the answer very short. 1.12. What is the ratio of the Employment to population ratio(%) of Venezuela in 1993 to that in 1999?
Offer a very short reply. 0.98. What is the ratio of the Employment to population ratio(%) in Lower middle income in 1993 to that in 2000?
Your response must be concise. 1.04. What is the ratio of the Employment to population ratio(%) of Lesotho in 1993 to that in 2000?
Ensure brevity in your answer.  0.93. What is the ratio of the Employment to population ratio(%) in Paraguay in 1993 to that in 2000?
Offer a very short reply. 1.15. What is the ratio of the Employment to population ratio(%) in Venezuela in 1993 to that in 2000?
Provide a succinct answer. 1.02. What is the ratio of the Employment to population ratio(%) in Lower middle income in 1994 to that in 1995?
Give a very brief answer. 1. What is the ratio of the Employment to population ratio(%) of Lesotho in 1994 to that in 1995?
Your answer should be compact. 1.04. What is the ratio of the Employment to population ratio(%) of Paraguay in 1994 to that in 1995?
Give a very brief answer. 0.96. What is the ratio of the Employment to population ratio(%) of Lesotho in 1994 to that in 1996?
Your response must be concise. 0.99. What is the ratio of the Employment to population ratio(%) of Paraguay in 1994 to that in 1996?
Ensure brevity in your answer.  1.01. What is the ratio of the Employment to population ratio(%) of Venezuela in 1994 to that in 1996?
Your answer should be compact. 1.03. What is the ratio of the Employment to population ratio(%) in Lower middle income in 1994 to that in 1997?
Keep it short and to the point. 1.02. What is the ratio of the Employment to population ratio(%) of Lesotho in 1994 to that in 1997?
Ensure brevity in your answer.  1.17. What is the ratio of the Employment to population ratio(%) of Paraguay in 1994 to that in 1997?
Offer a terse response. 1.06. What is the ratio of the Employment to population ratio(%) of Venezuela in 1994 to that in 1997?
Your answer should be very brief. 0.95. What is the ratio of the Employment to population ratio(%) in Lower middle income in 1994 to that in 1998?
Offer a very short reply. 1.04. What is the ratio of the Employment to population ratio(%) of Lesotho in 1994 to that in 1998?
Give a very brief answer. 1.07. What is the ratio of the Employment to population ratio(%) of Paraguay in 1994 to that in 1998?
Your answer should be compact. 1.1. What is the ratio of the Employment to population ratio(%) of Venezuela in 1994 to that in 1998?
Provide a succinct answer. 0.96. What is the ratio of the Employment to population ratio(%) of Lower middle income in 1994 to that in 1999?
Give a very brief answer. 1.02. What is the ratio of the Employment to population ratio(%) in Paraguay in 1994 to that in 1999?
Provide a short and direct response. 1.13. What is the ratio of the Employment to population ratio(%) of Lower middle income in 1994 to that in 2000?
Make the answer very short. 1.04. What is the ratio of the Employment to population ratio(%) in Lesotho in 1994 to that in 2000?
Provide a short and direct response. 1.05. What is the ratio of the Employment to population ratio(%) in Paraguay in 1994 to that in 2000?
Your answer should be compact. 1.16. What is the ratio of the Employment to population ratio(%) of Venezuela in 1994 to that in 2000?
Your response must be concise. 1.05. What is the ratio of the Employment to population ratio(%) of Lower middle income in 1995 to that in 1996?
Ensure brevity in your answer.  1. What is the ratio of the Employment to population ratio(%) in Lesotho in 1995 to that in 1996?
Provide a short and direct response. 0.95. What is the ratio of the Employment to population ratio(%) of Paraguay in 1995 to that in 1996?
Provide a succinct answer. 1.05. What is the ratio of the Employment to population ratio(%) of Venezuela in 1995 to that in 1996?
Your answer should be compact. 1.04. What is the ratio of the Employment to population ratio(%) of Lower middle income in 1995 to that in 1997?
Keep it short and to the point. 1.01. What is the ratio of the Employment to population ratio(%) of Lesotho in 1995 to that in 1997?
Make the answer very short. 1.13. What is the ratio of the Employment to population ratio(%) in Paraguay in 1995 to that in 1997?
Your response must be concise. 1.1. What is the ratio of the Employment to population ratio(%) in Venezuela in 1995 to that in 1997?
Your answer should be very brief. 0.95. What is the ratio of the Employment to population ratio(%) of Lower middle income in 1995 to that in 1998?
Give a very brief answer. 1.04. What is the ratio of the Employment to population ratio(%) in Lesotho in 1995 to that in 1998?
Ensure brevity in your answer.  1.04. What is the ratio of the Employment to population ratio(%) of Paraguay in 1995 to that in 1998?
Your answer should be very brief. 1.15. What is the ratio of the Employment to population ratio(%) in Venezuela in 1995 to that in 1998?
Offer a very short reply. 0.97. What is the ratio of the Employment to population ratio(%) of Lower middle income in 1995 to that in 1999?
Make the answer very short. 1.02. What is the ratio of the Employment to population ratio(%) in Lesotho in 1995 to that in 1999?
Provide a short and direct response. 0.95. What is the ratio of the Employment to population ratio(%) of Paraguay in 1995 to that in 1999?
Offer a very short reply. 1.18. What is the ratio of the Employment to population ratio(%) of Venezuela in 1995 to that in 1999?
Ensure brevity in your answer.  1.01. What is the ratio of the Employment to population ratio(%) in Lower middle income in 1995 to that in 2000?
Offer a terse response. 1.04. What is the ratio of the Employment to population ratio(%) in Lesotho in 1995 to that in 2000?
Keep it short and to the point. 1.01. What is the ratio of the Employment to population ratio(%) in Paraguay in 1995 to that in 2000?
Your answer should be compact. 1.21. What is the ratio of the Employment to population ratio(%) of Venezuela in 1995 to that in 2000?
Offer a terse response. 1.05. What is the ratio of the Employment to population ratio(%) in Lower middle income in 1996 to that in 1997?
Make the answer very short. 1.01. What is the ratio of the Employment to population ratio(%) in Lesotho in 1996 to that in 1997?
Offer a very short reply. 1.18. What is the ratio of the Employment to population ratio(%) in Paraguay in 1996 to that in 1997?
Offer a terse response. 1.05. What is the ratio of the Employment to population ratio(%) of Lower middle income in 1996 to that in 1998?
Your answer should be very brief. 1.04. What is the ratio of the Employment to population ratio(%) of Lesotho in 1996 to that in 1998?
Provide a short and direct response. 1.09. What is the ratio of the Employment to population ratio(%) in Paraguay in 1996 to that in 1998?
Ensure brevity in your answer.  1.09. What is the ratio of the Employment to population ratio(%) of Venezuela in 1996 to that in 1998?
Keep it short and to the point. 0.93. What is the ratio of the Employment to population ratio(%) in Lower middle income in 1996 to that in 1999?
Ensure brevity in your answer.  1.02. What is the ratio of the Employment to population ratio(%) in Lesotho in 1996 to that in 1999?
Provide a short and direct response. 1. What is the ratio of the Employment to population ratio(%) of Paraguay in 1996 to that in 1999?
Give a very brief answer. 1.13. What is the ratio of the Employment to population ratio(%) of Venezuela in 1996 to that in 1999?
Make the answer very short. 0.97. What is the ratio of the Employment to population ratio(%) in Lower middle income in 1996 to that in 2000?
Ensure brevity in your answer.  1.04. What is the ratio of the Employment to population ratio(%) of Lesotho in 1996 to that in 2000?
Provide a succinct answer. 1.07. What is the ratio of the Employment to population ratio(%) of Paraguay in 1996 to that in 2000?
Give a very brief answer. 1.16. What is the ratio of the Employment to population ratio(%) in Venezuela in 1996 to that in 2000?
Your answer should be compact. 1.02. What is the ratio of the Employment to population ratio(%) of Lower middle income in 1997 to that in 1998?
Provide a succinct answer. 1.02. What is the ratio of the Employment to population ratio(%) in Lesotho in 1997 to that in 1998?
Provide a short and direct response. 0.92. What is the ratio of the Employment to population ratio(%) of Paraguay in 1997 to that in 1998?
Your response must be concise. 1.04. What is the ratio of the Employment to population ratio(%) in Venezuela in 1997 to that in 1998?
Your answer should be compact. 1.01. What is the ratio of the Employment to population ratio(%) of Lower middle income in 1997 to that in 1999?
Give a very brief answer. 1.01. What is the ratio of the Employment to population ratio(%) of Lesotho in 1997 to that in 1999?
Give a very brief answer. 0.85. What is the ratio of the Employment to population ratio(%) of Paraguay in 1997 to that in 1999?
Offer a very short reply. 1.07. What is the ratio of the Employment to population ratio(%) of Venezuela in 1997 to that in 1999?
Give a very brief answer. 1.06. What is the ratio of the Employment to population ratio(%) of Lower middle income in 1997 to that in 2000?
Make the answer very short. 1.02. What is the ratio of the Employment to population ratio(%) of Lesotho in 1997 to that in 2000?
Provide a short and direct response. 0.9. What is the ratio of the Employment to population ratio(%) of Paraguay in 1997 to that in 2000?
Provide a short and direct response. 1.1. What is the ratio of the Employment to population ratio(%) of Venezuela in 1997 to that in 2000?
Offer a terse response. 1.11. What is the ratio of the Employment to population ratio(%) of Lower middle income in 1998 to that in 1999?
Your answer should be very brief. 0.98. What is the ratio of the Employment to population ratio(%) in Lesotho in 1998 to that in 1999?
Keep it short and to the point. 0.92. What is the ratio of the Employment to population ratio(%) of Paraguay in 1998 to that in 1999?
Provide a succinct answer. 1.03. What is the ratio of the Employment to population ratio(%) in Venezuela in 1998 to that in 1999?
Offer a terse response. 1.04. What is the ratio of the Employment to population ratio(%) of Lower middle income in 1998 to that in 2000?
Your answer should be very brief. 1. What is the ratio of the Employment to population ratio(%) of Lesotho in 1998 to that in 2000?
Provide a short and direct response. 0.98. What is the ratio of the Employment to population ratio(%) of Paraguay in 1998 to that in 2000?
Provide a short and direct response. 1.06. What is the ratio of the Employment to population ratio(%) in Venezuela in 1998 to that in 2000?
Offer a very short reply. 1.09. What is the ratio of the Employment to population ratio(%) of Lower middle income in 1999 to that in 2000?
Your answer should be compact. 1.02. What is the ratio of the Employment to population ratio(%) in Lesotho in 1999 to that in 2000?
Provide a short and direct response. 1.06. What is the ratio of the Employment to population ratio(%) of Paraguay in 1999 to that in 2000?
Your answer should be compact. 1.03. What is the ratio of the Employment to population ratio(%) of Venezuela in 1999 to that in 2000?
Keep it short and to the point. 1.05. What is the difference between the highest and the second highest Employment to population ratio(%) of Lower middle income?
Keep it short and to the point. 0.04. What is the difference between the highest and the second highest Employment to population ratio(%) in Lesotho?
Your answer should be very brief. 0.2. What is the difference between the highest and the second highest Employment to population ratio(%) in Venezuela?
Give a very brief answer. 0.8. What is the difference between the highest and the lowest Employment to population ratio(%) in Lower middle income?
Ensure brevity in your answer.  2.17. What is the difference between the highest and the lowest Employment to population ratio(%) in Paraguay?
Provide a short and direct response. 14.4. What is the difference between the highest and the lowest Employment to population ratio(%) of Venezuela?
Your response must be concise. 5.3. 